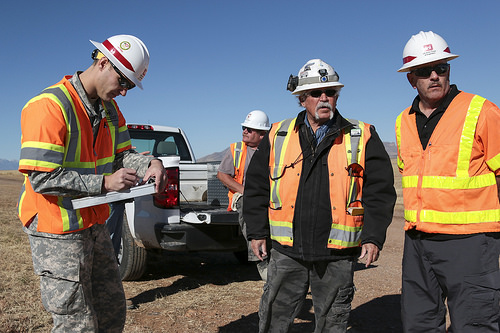<image>
Can you confirm if the helmet is above the pants? Yes. The helmet is positioned above the pants in the vertical space, higher up in the scene. 